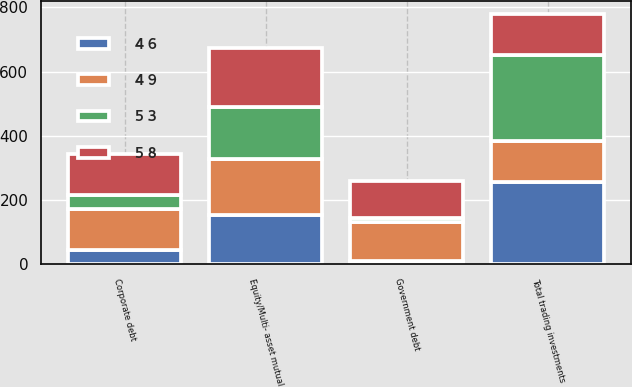Convert chart to OTSL. <chart><loc_0><loc_0><loc_500><loc_500><stacked_bar_chart><ecel><fcel>Equity/Multi- asset mutual<fcel>Corporate debt<fcel>Government debt<fcel>Total trading investments<nl><fcel>4 9<fcel>174<fcel>128<fcel>121<fcel>128<nl><fcel>5 8<fcel>184<fcel>128<fcel>116<fcel>128<nl><fcel>4 6<fcel>154<fcel>44<fcel>11<fcel>255<nl><fcel>5 3<fcel>162<fcel>44<fcel>11<fcel>270<nl></chart> 